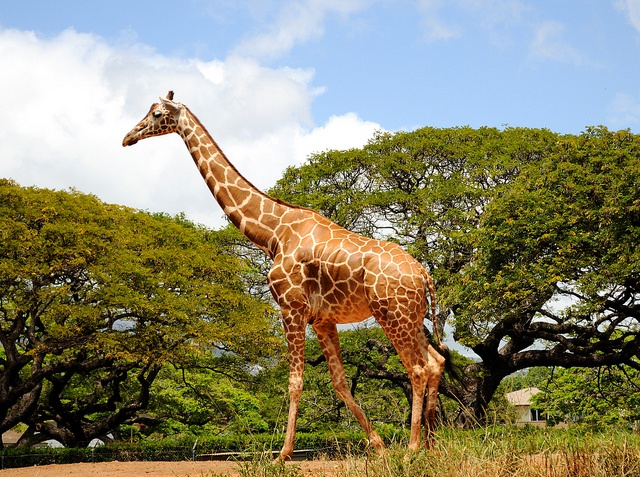Describe the objects in this image and their specific colors. I can see a giraffe in lightblue, brown, tan, and maroon tones in this image. 